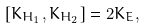<formula> <loc_0><loc_0><loc_500><loc_500>\left [ K _ { H _ { 1 } } , K _ { H _ { 2 } } \right ] = 2 K _ { E } ,</formula> 